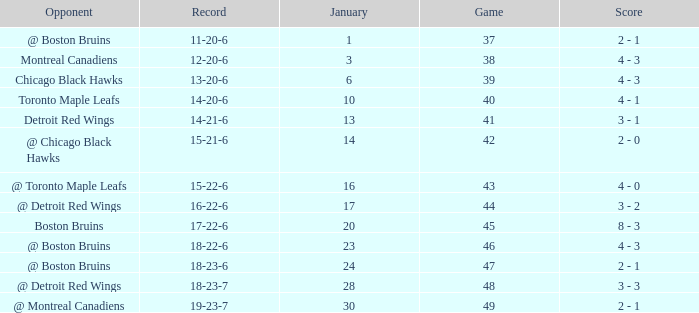What day in January was the game greater than 49 and had @ Montreal Canadiens as opponents? None. 